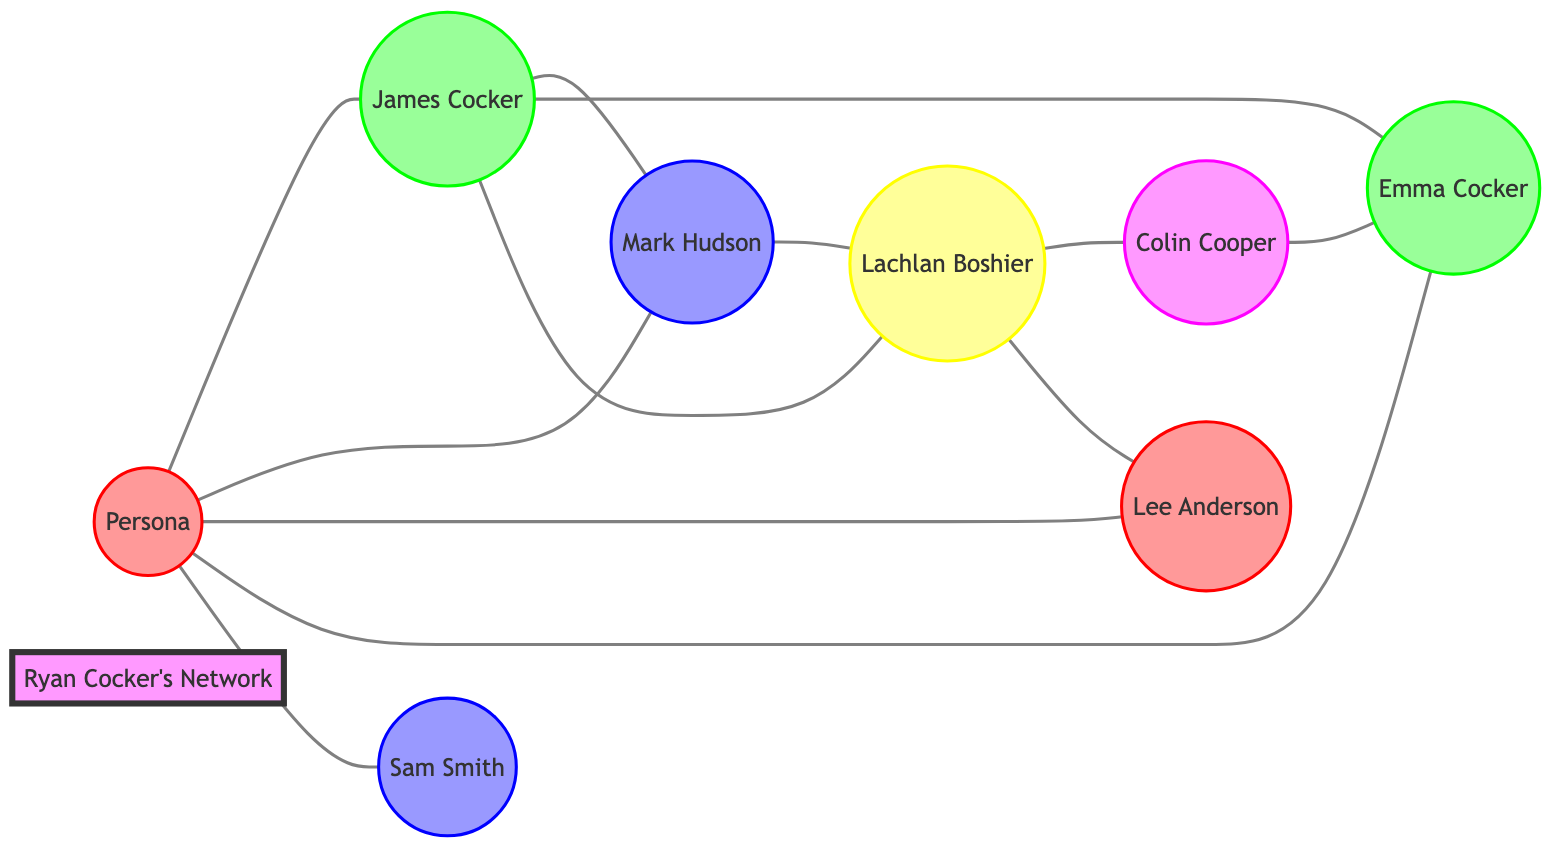What is the total number of nodes in the graph? To find the total number of nodes, we count each unique character in the nodes list provided in the data: there are 8 nodes.
Answer: 8 Who is connected to Ryan Cocker as a family member? By examining the edges, I see that there are connections from the "Persona" node to "James Cocker" and "Emma Cocker," both of whom are labeled as family members.
Answer: James Cocker, Emma Cocker What type of connection do Mark Hudson and James Cocker share? The edge between "Mark Hudson" and "James Cocker" is labeled as "Mutual friends," indicating the nature of their relationship.
Answer: Mutual friends How many direct connections does Lachlan Boshier have? Lachlan Boshier is connected to three nodes: "James Cocker," "Mark Hudson," and "Lee Anderson." Counting these connections gives us a total of 3.
Answer: 3 Which node has a direct connection with both Colin Cooper and Emma Cocker? The "Lachlan Boshier" node is connected to "Colin Cooper" and has an indirect connection to "Emma Cocker" through other nodes. However, the only direct relationship established in the data is with "Colin Cooper."
Answer: Lachlan Boshier Is there any friend connected to the main fan character? The "Persona" node has direct edges with "Mark Hudson" and "Sam Smith," both labeled as friends, indicating their connection.
Answer: Yes, Mark Hudson, Sam Smith What is the relationship type between Lachlan Boshier and Colin Cooper? The edge between "Lachlan Boshier" and "Colin Cooper" is described by "Player-coach relationship," which describes their connection.
Answer: Player-coach relationship Which family member is not directly connected to the fan? "Emma Cocker" is generally connected while being labeled as a family member, but the direct edge only connects "James Cocker" and "Persona," indicating no direct connection.
Answer: Emma Cocker 